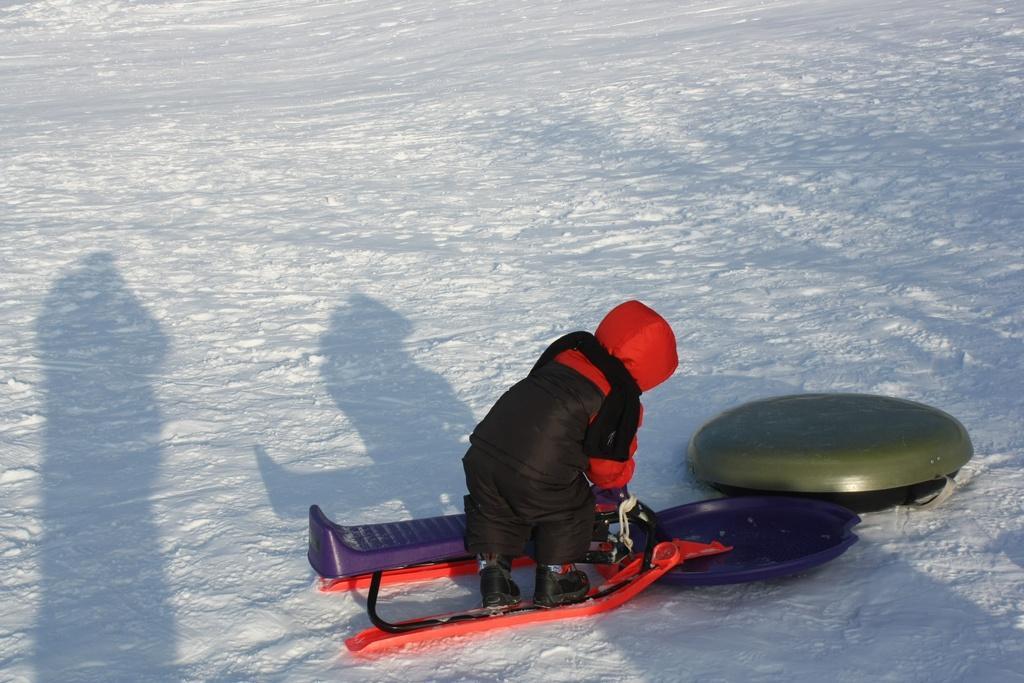How would you summarize this image in a sentence or two? In the foreground, I can see a person is holding an object in hand and I can see some objects on the road and snow. This image taken, maybe during a day. 